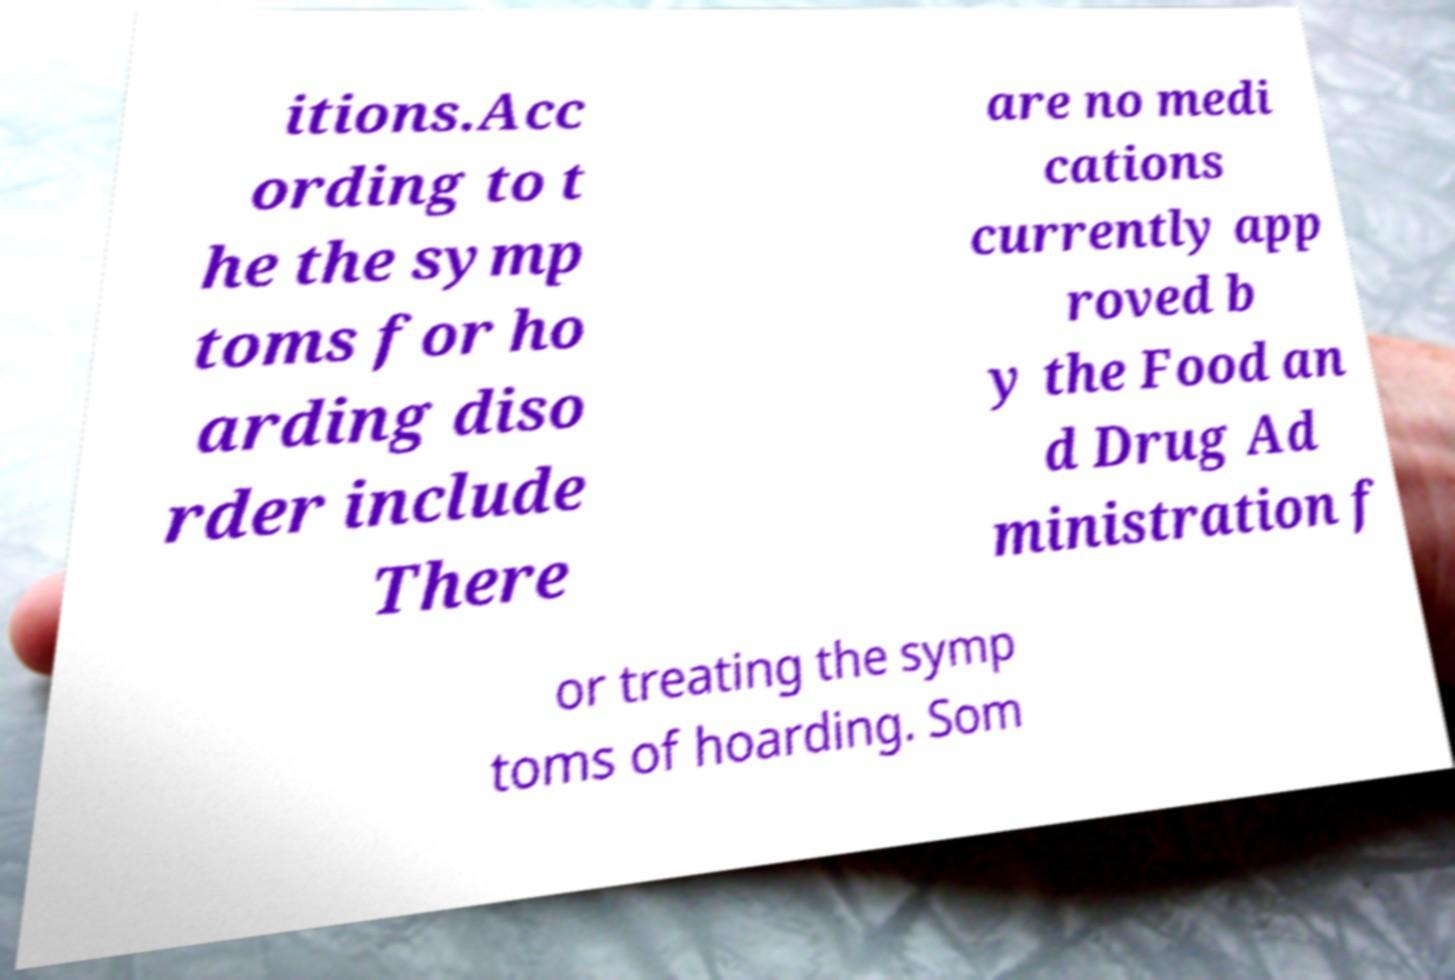For documentation purposes, I need the text within this image transcribed. Could you provide that? itions.Acc ording to t he the symp toms for ho arding diso rder include There are no medi cations currently app roved b y the Food an d Drug Ad ministration f or treating the symp toms of hoarding. Som 